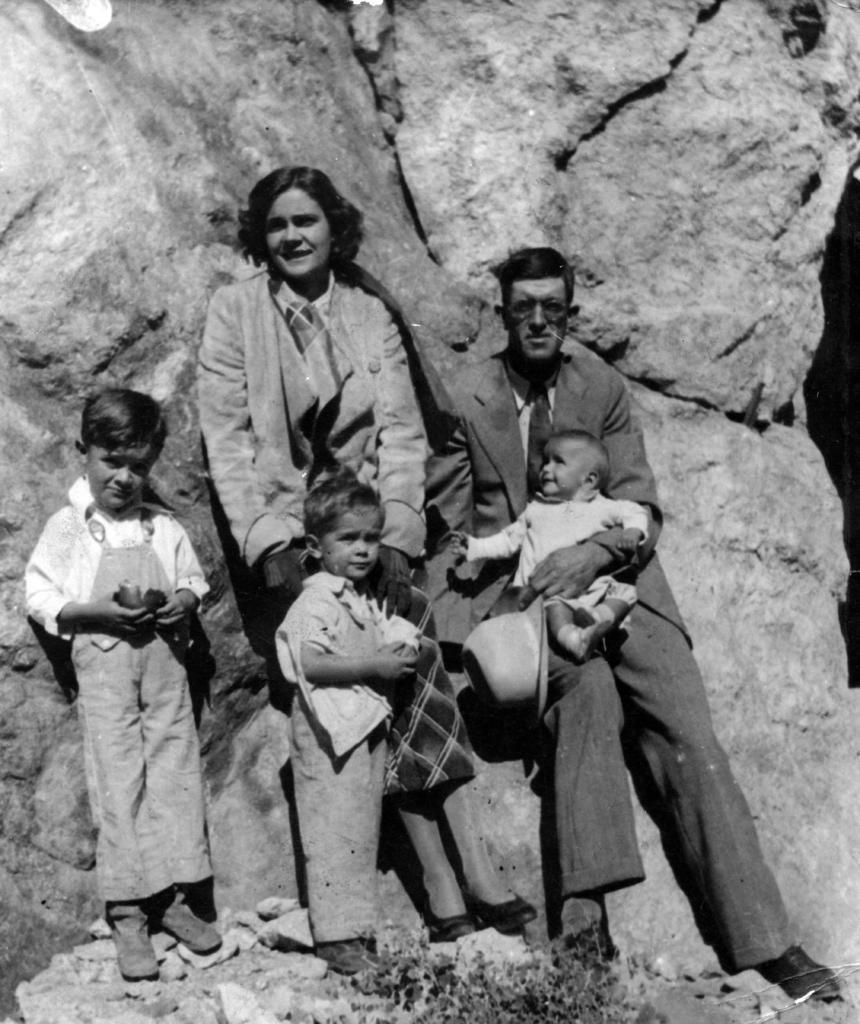Can you describe this image briefly? In this picture there is a woman standing and there is a man sitting and holding the baby and he is holding the hat and there are two kids standing. At the back there are rocks. At the bottom there is a plant and there are stones. 